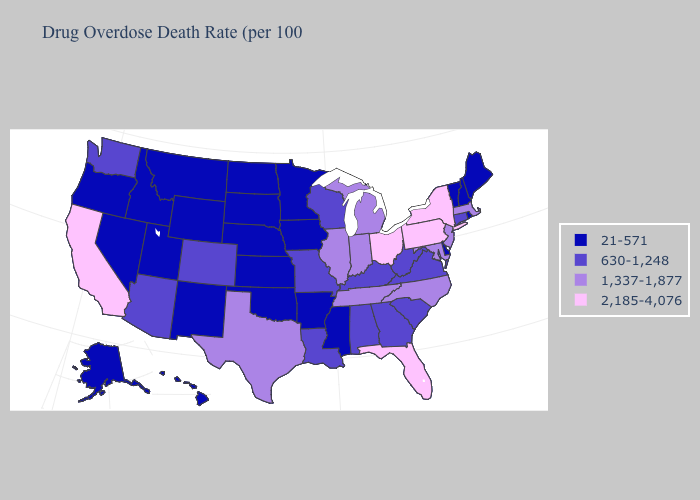Among the states that border Georgia , which have the highest value?
Short answer required. Florida. Does the map have missing data?
Quick response, please. No. Which states have the highest value in the USA?
Concise answer only. California, Florida, New York, Ohio, Pennsylvania. Name the states that have a value in the range 1,337-1,877?
Quick response, please. Illinois, Indiana, Maryland, Massachusetts, Michigan, New Jersey, North Carolina, Tennessee, Texas. Which states have the highest value in the USA?
Write a very short answer. California, Florida, New York, Ohio, Pennsylvania. Does the first symbol in the legend represent the smallest category?
Quick response, please. Yes. Does Wisconsin have the lowest value in the USA?
Be succinct. No. Does Idaho have the lowest value in the USA?
Answer briefly. Yes. What is the value of Indiana?
Give a very brief answer. 1,337-1,877. Name the states that have a value in the range 2,185-4,076?
Concise answer only. California, Florida, New York, Ohio, Pennsylvania. What is the highest value in the West ?
Keep it brief. 2,185-4,076. Does Delaware have the highest value in the USA?
Write a very short answer. No. What is the lowest value in states that border Nebraska?
Quick response, please. 21-571. What is the value of Oregon?
Short answer required. 21-571. Is the legend a continuous bar?
Answer briefly. No. 